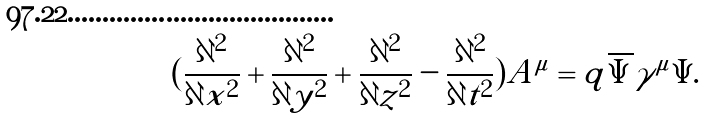<formula> <loc_0><loc_0><loc_500><loc_500>( \frac { \partial ^ { 2 } } { \partial x ^ { 2 } } + \frac { \partial ^ { 2 } } { \partial y ^ { 2 } } + \frac { \partial ^ { 2 } } { \partial z ^ { 2 } } - \frac { \partial ^ { 2 } } { \partial t ^ { 2 } } ) A ^ { \mu } = q \overline { \Psi } \gamma ^ { \mu } \Psi .</formula> 